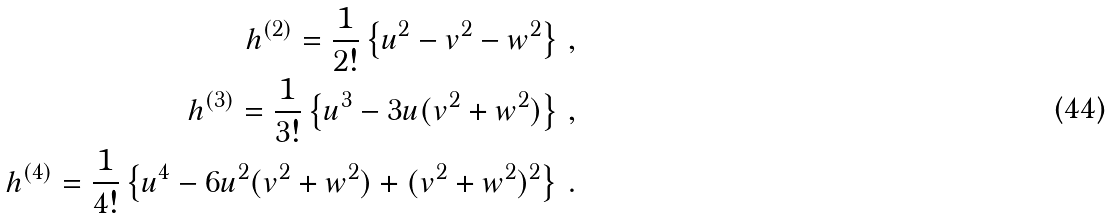<formula> <loc_0><loc_0><loc_500><loc_500>h ^ { ( 2 ) } = \frac { 1 } { 2 ! } \left \{ u ^ { 2 } - v ^ { 2 } - w ^ { 2 } \right \} \, , \\ h ^ { ( 3 ) } = \frac { 1 } { 3 ! } \left \{ u ^ { 3 } - 3 u ( v ^ { 2 } + w ^ { 2 } ) \right \} \, , \\ h ^ { ( 4 ) } = \frac { 1 } { 4 ! } \left \{ u ^ { 4 } - 6 u ^ { 2 } ( v ^ { 2 } + w ^ { 2 } ) + ( v ^ { 2 } + w ^ { 2 } ) ^ { 2 } \right \} \, .</formula> 